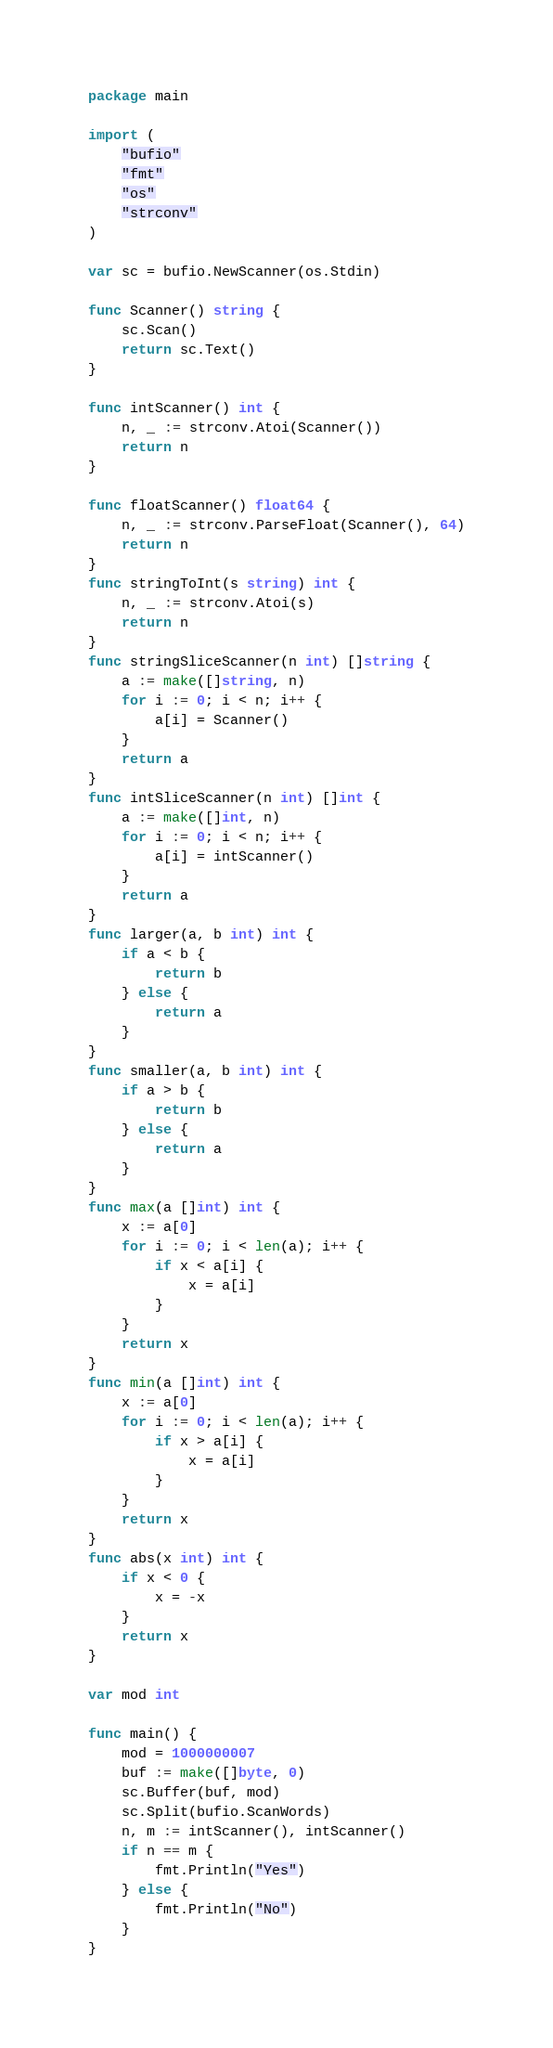<code> <loc_0><loc_0><loc_500><loc_500><_Go_>package main

import (
	"bufio"
	"fmt"
	"os"
	"strconv"
)

var sc = bufio.NewScanner(os.Stdin)

func Scanner() string {
	sc.Scan()
	return sc.Text()
}

func intScanner() int {
	n, _ := strconv.Atoi(Scanner())
	return n
}

func floatScanner() float64 {
	n, _ := strconv.ParseFloat(Scanner(), 64)
	return n
}
func stringToInt(s string) int {
	n, _ := strconv.Atoi(s)
	return n
}
func stringSliceScanner(n int) []string {
	a := make([]string, n)
	for i := 0; i < n; i++ {
		a[i] = Scanner()
	}
	return a
}
func intSliceScanner(n int) []int {
	a := make([]int, n)
	for i := 0; i < n; i++ {
		a[i] = intScanner()
	}
	return a
}
func larger(a, b int) int {
	if a < b {
		return b
	} else {
		return a
	}
}
func smaller(a, b int) int {
	if a > b {
		return b
	} else {
		return a
	}
}
func max(a []int) int {
	x := a[0]
	for i := 0; i < len(a); i++ {
		if x < a[i] {
			x = a[i]
		}
	}
	return x
}
func min(a []int) int {
	x := a[0]
	for i := 0; i < len(a); i++ {
		if x > a[i] {
			x = a[i]
		}
	}
	return x
}
func abs(x int) int {
	if x < 0 {
		x = -x
	}
	return x
}

var mod int

func main() {
	mod = 1000000007
	buf := make([]byte, 0)
	sc.Buffer(buf, mod)
	sc.Split(bufio.ScanWords)
	n, m := intScanner(), intScanner()
	if n == m {
		fmt.Println("Yes")
	} else {
		fmt.Println("No")
	}
}
</code> 